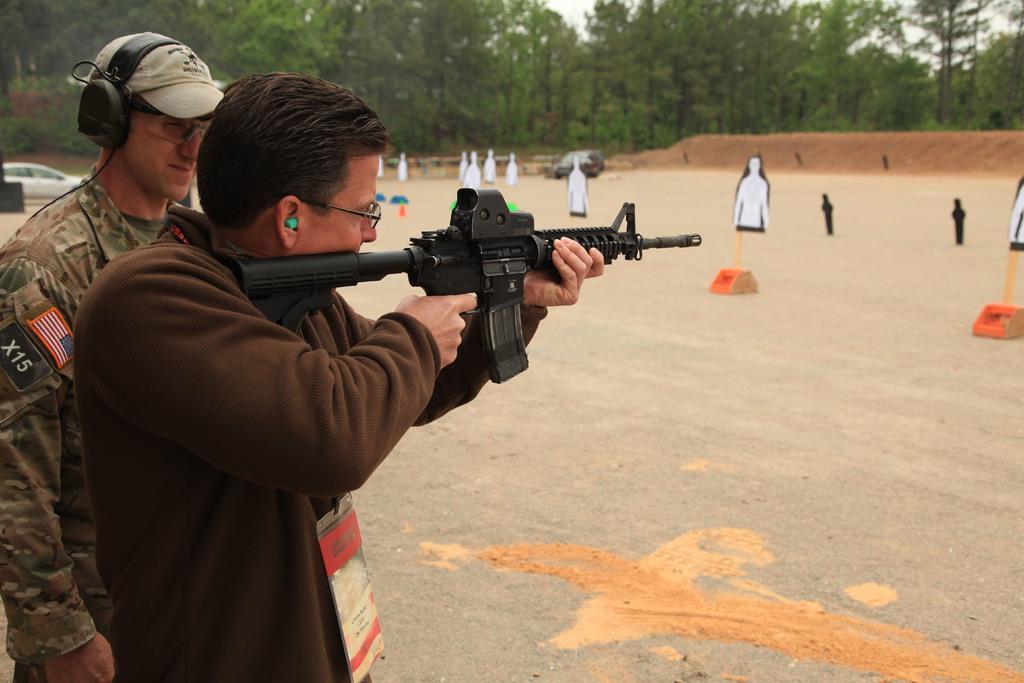Please provide a concise description of this image. In this image on the left side there are two persons standing, and one person is holding a gun and one person is wearing a headset. In the background there are some wooden sticks, sand, trees and some objects. At the bottom there is sand and on the left side there is car. 